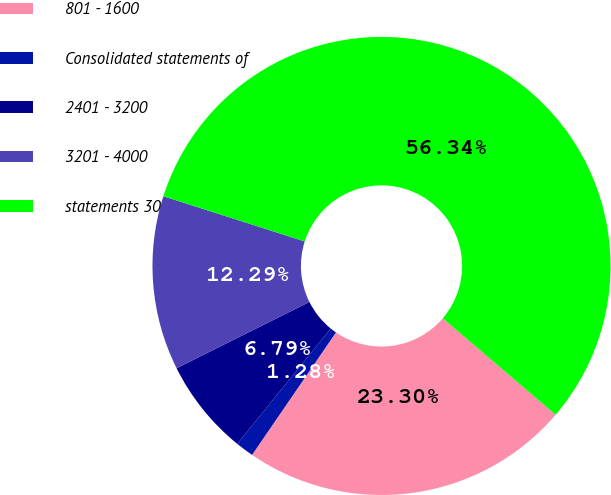<chart> <loc_0><loc_0><loc_500><loc_500><pie_chart><fcel>801 - 1600<fcel>Consolidated statements of<fcel>2401 - 3200<fcel>3201 - 4000<fcel>statements 30<nl><fcel>23.3%<fcel>1.28%<fcel>6.79%<fcel>12.29%<fcel>56.33%<nl></chart> 